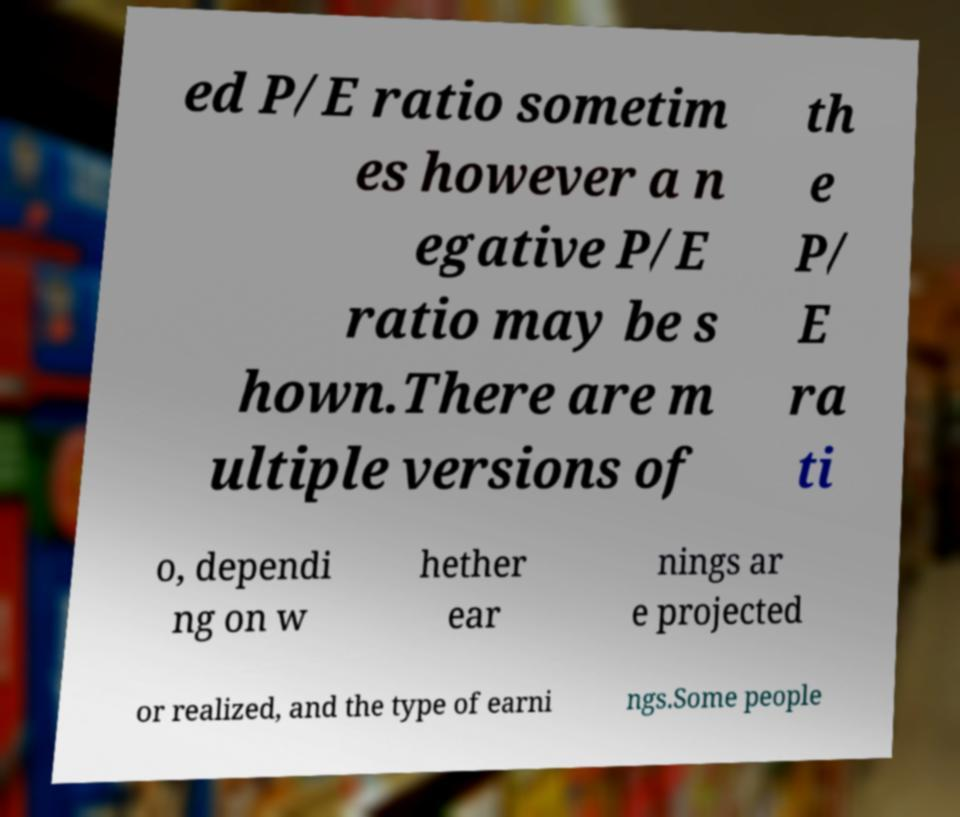Can you read and provide the text displayed in the image?This photo seems to have some interesting text. Can you extract and type it out for me? ed P/E ratio sometim es however a n egative P/E ratio may be s hown.There are m ultiple versions of th e P/ E ra ti o, dependi ng on w hether ear nings ar e projected or realized, and the type of earni ngs.Some people 